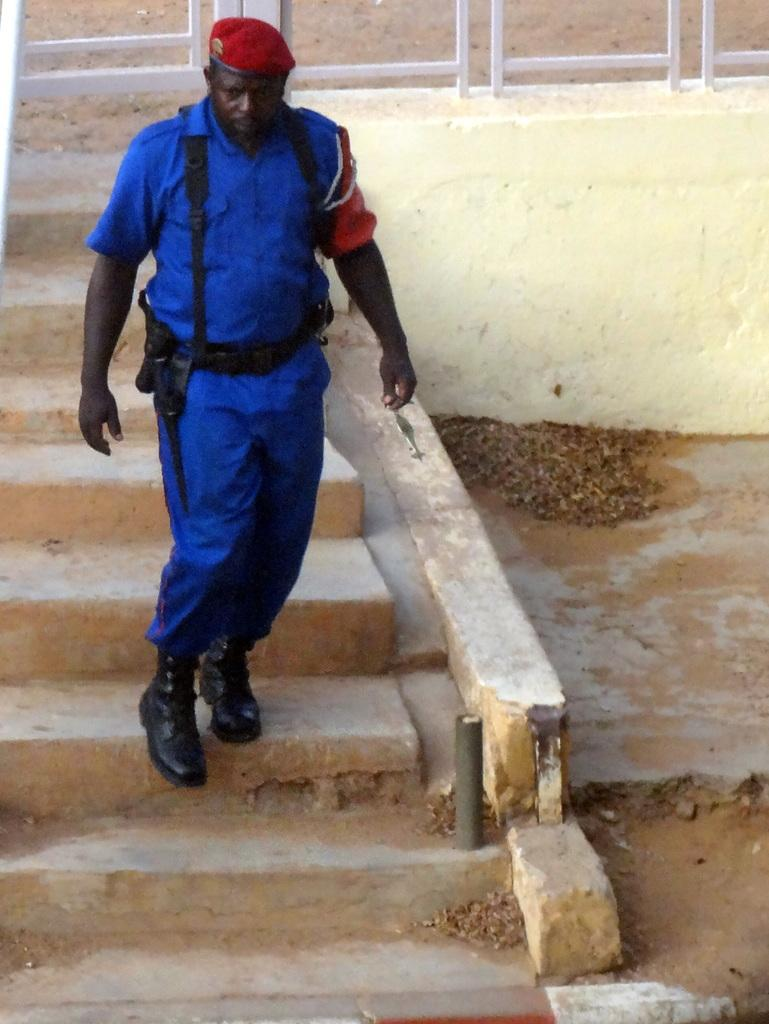Who is the main subject in the image? There is a man in the center of the image. What is the man wearing? The man is wearing a blue dress and a red hat. What can be seen in the background of the image? There are steps and a white fence in the background of the image. What type of animal is the man riding in the image? There is no animal present in the image, and the man is not riding anything. 